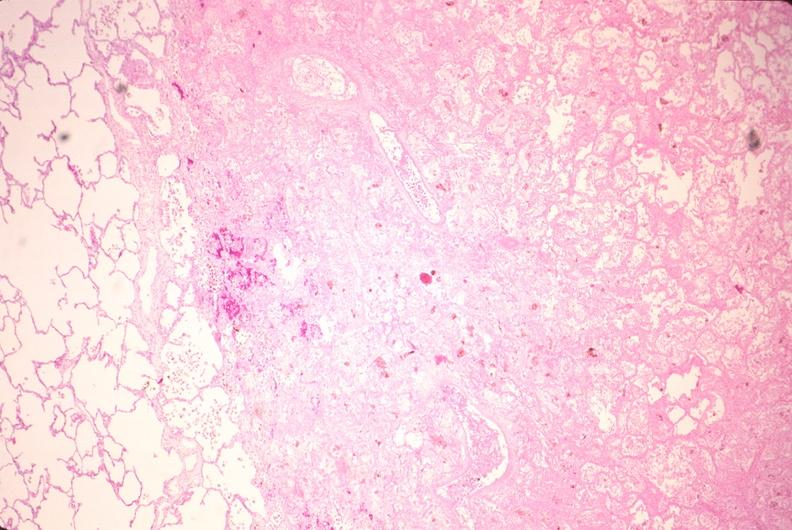what does this image show?
Answer the question using a single word or phrase. Lung 